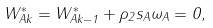<formula> <loc_0><loc_0><loc_500><loc_500>W ^ { * } _ { A k } = W ^ { * } _ { A k - 1 } + \rho _ { 2 } s _ { A } \omega _ { A } = 0 ,</formula> 